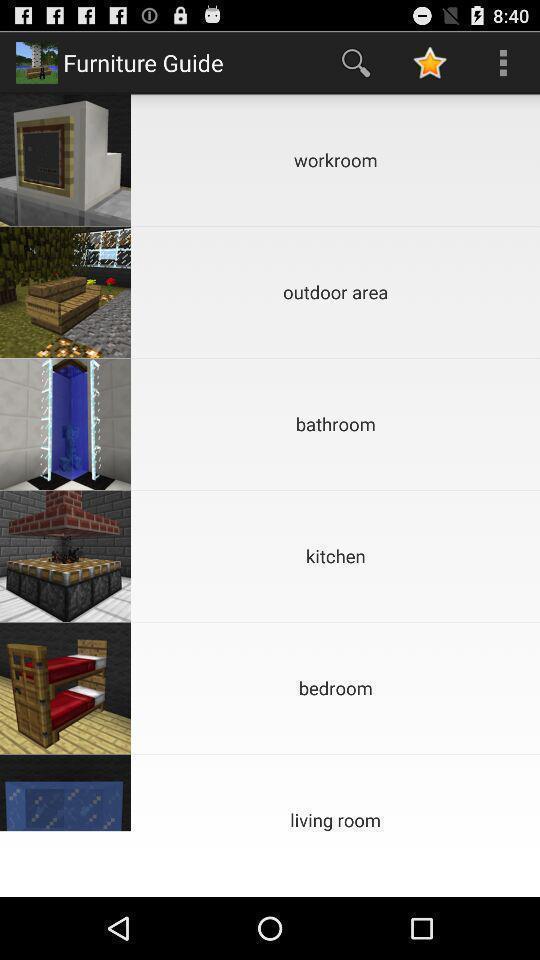Provide a textual representation of this image. Pop-up showing menu with different options. 